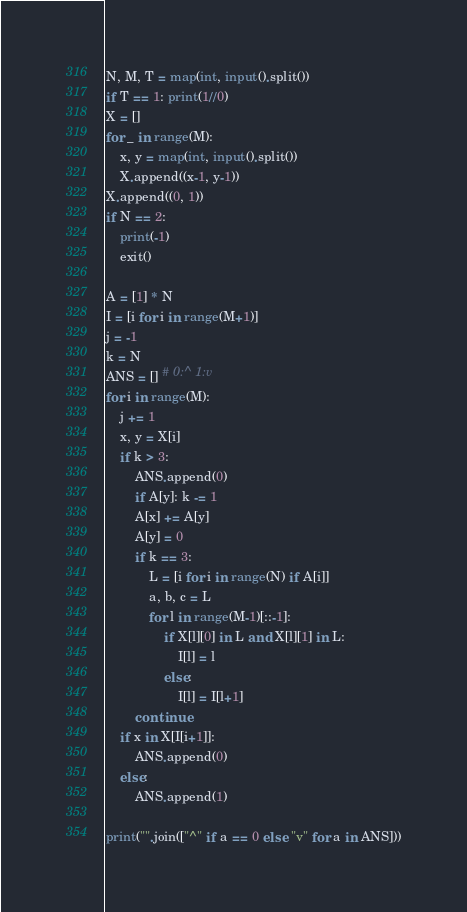Convert code to text. <code><loc_0><loc_0><loc_500><loc_500><_Python_>N, M, T = map(int, input().split())
if T == 1: print(1//0)
X = []
for _ in range(M):
    x, y = map(int, input().split())
    X.append((x-1, y-1))
X.append((0, 1))
if N == 2:
    print(-1)
    exit()

A = [1] * N
I = [i for i in range(M+1)]
j = -1
k = N
ANS = [] # 0:^ 1:v
for i in range(M):
    j += 1
    x, y = X[i]
    if k > 3:
        ANS.append(0)
        if A[y]: k -= 1
        A[x] += A[y]
        A[y] = 0
        if k == 3:
            L = [i for i in range(N) if A[i]]
            a, b, c = L
            for l in range(M-1)[::-1]:
                if X[l][0] in L and X[l][1] in L:
                    I[l] = l
                else:
                    I[l] = I[l+1]
        continue
    if x in X[I[i+1]]:
        ANS.append(0)
    else:
        ANS.append(1)

print("".join(["^" if a == 0 else "v" for a in ANS]))</code> 